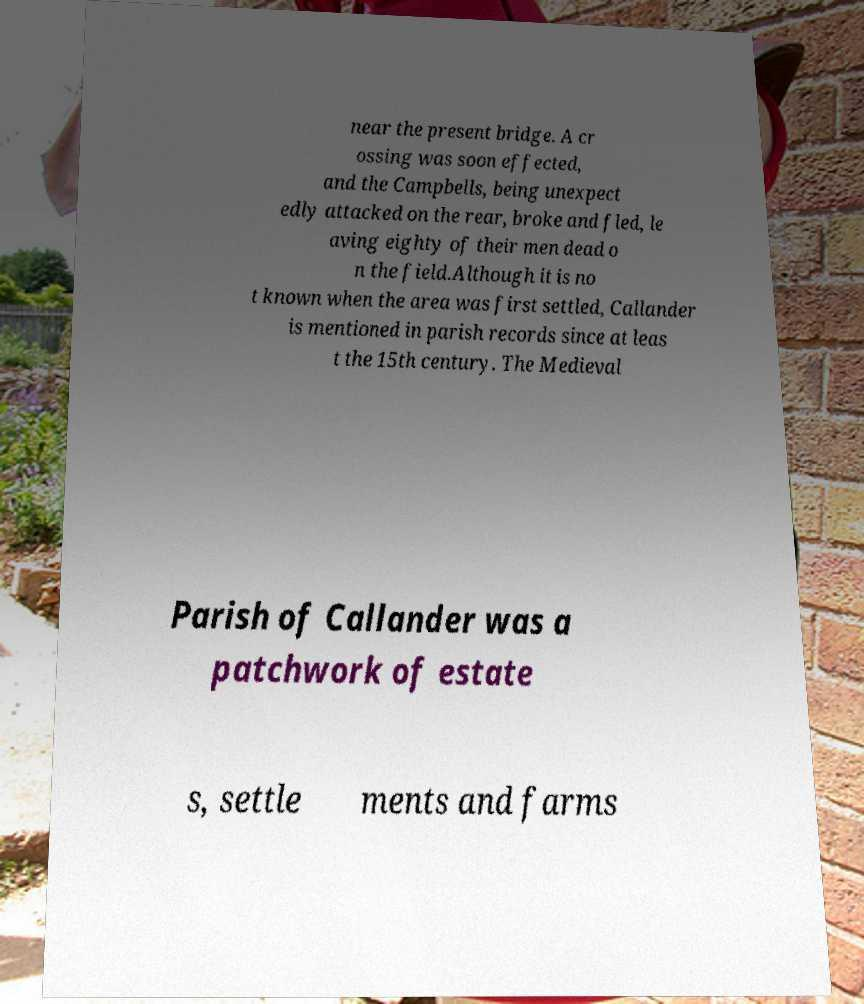Could you assist in decoding the text presented in this image and type it out clearly? near the present bridge. A cr ossing was soon effected, and the Campbells, being unexpect edly attacked on the rear, broke and fled, le aving eighty of their men dead o n the field.Although it is no t known when the area was first settled, Callander is mentioned in parish records since at leas t the 15th century. The Medieval Parish of Callander was a patchwork of estate s, settle ments and farms 